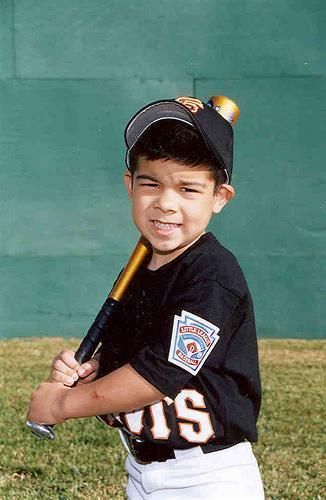How many wheels does the skateboard have?
Give a very brief answer. 0. 